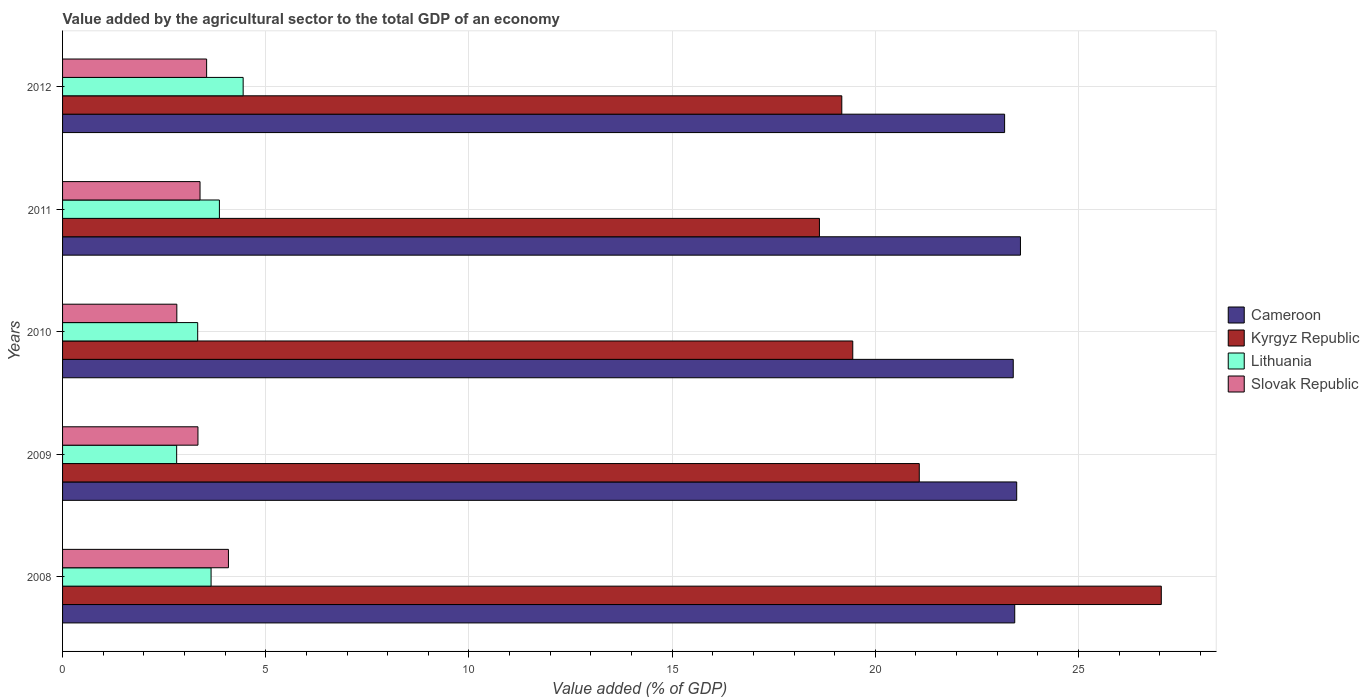Are the number of bars per tick equal to the number of legend labels?
Your answer should be compact. Yes. What is the label of the 1st group of bars from the top?
Make the answer very short. 2012. What is the value added by the agricultural sector to the total GDP in Slovak Republic in 2008?
Your response must be concise. 4.08. Across all years, what is the maximum value added by the agricultural sector to the total GDP in Slovak Republic?
Offer a terse response. 4.08. Across all years, what is the minimum value added by the agricultural sector to the total GDP in Lithuania?
Your answer should be compact. 2.81. In which year was the value added by the agricultural sector to the total GDP in Lithuania maximum?
Your answer should be compact. 2012. In which year was the value added by the agricultural sector to the total GDP in Lithuania minimum?
Your response must be concise. 2009. What is the total value added by the agricultural sector to the total GDP in Lithuania in the graph?
Provide a short and direct response. 18.09. What is the difference between the value added by the agricultural sector to the total GDP in Slovak Republic in 2008 and that in 2010?
Your answer should be very brief. 1.27. What is the difference between the value added by the agricultural sector to the total GDP in Cameroon in 2009 and the value added by the agricultural sector to the total GDP in Kyrgyz Republic in 2011?
Give a very brief answer. 4.85. What is the average value added by the agricultural sector to the total GDP in Slovak Republic per year?
Offer a terse response. 3.43. In the year 2012, what is the difference between the value added by the agricultural sector to the total GDP in Kyrgyz Republic and value added by the agricultural sector to the total GDP in Lithuania?
Your answer should be compact. 14.73. What is the ratio of the value added by the agricultural sector to the total GDP in Lithuania in 2009 to that in 2012?
Provide a short and direct response. 0.63. What is the difference between the highest and the second highest value added by the agricultural sector to the total GDP in Cameroon?
Offer a terse response. 0.09. What is the difference between the highest and the lowest value added by the agricultural sector to the total GDP in Cameroon?
Provide a succinct answer. 0.39. In how many years, is the value added by the agricultural sector to the total GDP in Kyrgyz Republic greater than the average value added by the agricultural sector to the total GDP in Kyrgyz Republic taken over all years?
Your answer should be very brief. 2. Is it the case that in every year, the sum of the value added by the agricultural sector to the total GDP in Cameroon and value added by the agricultural sector to the total GDP in Slovak Republic is greater than the sum of value added by the agricultural sector to the total GDP in Lithuania and value added by the agricultural sector to the total GDP in Kyrgyz Republic?
Your answer should be compact. Yes. What does the 4th bar from the top in 2009 represents?
Give a very brief answer. Cameroon. What does the 2nd bar from the bottom in 2009 represents?
Ensure brevity in your answer.  Kyrgyz Republic. Is it the case that in every year, the sum of the value added by the agricultural sector to the total GDP in Slovak Republic and value added by the agricultural sector to the total GDP in Kyrgyz Republic is greater than the value added by the agricultural sector to the total GDP in Lithuania?
Provide a short and direct response. Yes. Are all the bars in the graph horizontal?
Make the answer very short. Yes. How many years are there in the graph?
Make the answer very short. 5. What is the title of the graph?
Offer a very short reply. Value added by the agricultural sector to the total GDP of an economy. Does "Vanuatu" appear as one of the legend labels in the graph?
Ensure brevity in your answer.  No. What is the label or title of the X-axis?
Make the answer very short. Value added (% of GDP). What is the Value added (% of GDP) of Cameroon in 2008?
Give a very brief answer. 23.43. What is the Value added (% of GDP) in Kyrgyz Republic in 2008?
Your response must be concise. 27.04. What is the Value added (% of GDP) in Lithuania in 2008?
Your answer should be very brief. 3.65. What is the Value added (% of GDP) in Slovak Republic in 2008?
Make the answer very short. 4.08. What is the Value added (% of GDP) in Cameroon in 2009?
Make the answer very short. 23.48. What is the Value added (% of GDP) of Kyrgyz Republic in 2009?
Offer a terse response. 21.08. What is the Value added (% of GDP) in Lithuania in 2009?
Give a very brief answer. 2.81. What is the Value added (% of GDP) of Slovak Republic in 2009?
Provide a short and direct response. 3.33. What is the Value added (% of GDP) in Cameroon in 2010?
Your response must be concise. 23.39. What is the Value added (% of GDP) in Kyrgyz Republic in 2010?
Give a very brief answer. 19.44. What is the Value added (% of GDP) in Lithuania in 2010?
Keep it short and to the point. 3.33. What is the Value added (% of GDP) in Slovak Republic in 2010?
Give a very brief answer. 2.81. What is the Value added (% of GDP) in Cameroon in 2011?
Your answer should be very brief. 23.57. What is the Value added (% of GDP) in Kyrgyz Republic in 2011?
Provide a short and direct response. 18.62. What is the Value added (% of GDP) of Lithuania in 2011?
Offer a terse response. 3.86. What is the Value added (% of GDP) in Slovak Republic in 2011?
Your answer should be very brief. 3.38. What is the Value added (% of GDP) in Cameroon in 2012?
Your response must be concise. 23.18. What is the Value added (% of GDP) in Kyrgyz Republic in 2012?
Offer a terse response. 19.18. What is the Value added (% of GDP) of Lithuania in 2012?
Your answer should be very brief. 4.44. What is the Value added (% of GDP) of Slovak Republic in 2012?
Provide a succinct answer. 3.54. Across all years, what is the maximum Value added (% of GDP) of Cameroon?
Keep it short and to the point. 23.57. Across all years, what is the maximum Value added (% of GDP) of Kyrgyz Republic?
Your answer should be compact. 27.04. Across all years, what is the maximum Value added (% of GDP) in Lithuania?
Offer a very short reply. 4.44. Across all years, what is the maximum Value added (% of GDP) in Slovak Republic?
Your answer should be compact. 4.08. Across all years, what is the minimum Value added (% of GDP) in Cameroon?
Your response must be concise. 23.18. Across all years, what is the minimum Value added (% of GDP) of Kyrgyz Republic?
Provide a succinct answer. 18.62. Across all years, what is the minimum Value added (% of GDP) of Lithuania?
Ensure brevity in your answer.  2.81. Across all years, what is the minimum Value added (% of GDP) of Slovak Republic?
Your answer should be very brief. 2.81. What is the total Value added (% of GDP) in Cameroon in the graph?
Provide a succinct answer. 117.06. What is the total Value added (% of GDP) of Kyrgyz Republic in the graph?
Make the answer very short. 105.36. What is the total Value added (% of GDP) in Lithuania in the graph?
Your answer should be very brief. 18.09. What is the total Value added (% of GDP) in Slovak Republic in the graph?
Offer a very short reply. 17.15. What is the difference between the Value added (% of GDP) of Cameroon in 2008 and that in 2009?
Provide a short and direct response. -0.05. What is the difference between the Value added (% of GDP) in Kyrgyz Republic in 2008 and that in 2009?
Ensure brevity in your answer.  5.96. What is the difference between the Value added (% of GDP) of Lithuania in 2008 and that in 2009?
Make the answer very short. 0.85. What is the difference between the Value added (% of GDP) in Slovak Republic in 2008 and that in 2009?
Your answer should be very brief. 0.75. What is the difference between the Value added (% of GDP) of Cameroon in 2008 and that in 2010?
Provide a succinct answer. 0.04. What is the difference between the Value added (% of GDP) of Kyrgyz Republic in 2008 and that in 2010?
Provide a short and direct response. 7.59. What is the difference between the Value added (% of GDP) of Lithuania in 2008 and that in 2010?
Your answer should be very brief. 0.33. What is the difference between the Value added (% of GDP) of Slovak Republic in 2008 and that in 2010?
Offer a very short reply. 1.27. What is the difference between the Value added (% of GDP) of Cameroon in 2008 and that in 2011?
Ensure brevity in your answer.  -0.14. What is the difference between the Value added (% of GDP) of Kyrgyz Republic in 2008 and that in 2011?
Provide a succinct answer. 8.41. What is the difference between the Value added (% of GDP) of Lithuania in 2008 and that in 2011?
Your answer should be compact. -0.21. What is the difference between the Value added (% of GDP) in Slovak Republic in 2008 and that in 2011?
Ensure brevity in your answer.  0.7. What is the difference between the Value added (% of GDP) in Cameroon in 2008 and that in 2012?
Provide a succinct answer. 0.25. What is the difference between the Value added (% of GDP) of Kyrgyz Republic in 2008 and that in 2012?
Provide a short and direct response. 7.86. What is the difference between the Value added (% of GDP) of Lithuania in 2008 and that in 2012?
Ensure brevity in your answer.  -0.79. What is the difference between the Value added (% of GDP) in Slovak Republic in 2008 and that in 2012?
Offer a very short reply. 0.54. What is the difference between the Value added (% of GDP) in Cameroon in 2009 and that in 2010?
Your answer should be compact. 0.08. What is the difference between the Value added (% of GDP) in Kyrgyz Republic in 2009 and that in 2010?
Make the answer very short. 1.64. What is the difference between the Value added (% of GDP) in Lithuania in 2009 and that in 2010?
Provide a short and direct response. -0.52. What is the difference between the Value added (% of GDP) of Slovak Republic in 2009 and that in 2010?
Ensure brevity in your answer.  0.52. What is the difference between the Value added (% of GDP) of Cameroon in 2009 and that in 2011?
Give a very brief answer. -0.09. What is the difference between the Value added (% of GDP) of Kyrgyz Republic in 2009 and that in 2011?
Keep it short and to the point. 2.46. What is the difference between the Value added (% of GDP) in Lithuania in 2009 and that in 2011?
Give a very brief answer. -1.05. What is the difference between the Value added (% of GDP) in Slovak Republic in 2009 and that in 2011?
Provide a succinct answer. -0.05. What is the difference between the Value added (% of GDP) in Cameroon in 2009 and that in 2012?
Make the answer very short. 0.3. What is the difference between the Value added (% of GDP) of Kyrgyz Republic in 2009 and that in 2012?
Keep it short and to the point. 1.91. What is the difference between the Value added (% of GDP) in Lithuania in 2009 and that in 2012?
Ensure brevity in your answer.  -1.64. What is the difference between the Value added (% of GDP) of Slovak Republic in 2009 and that in 2012?
Provide a succinct answer. -0.21. What is the difference between the Value added (% of GDP) of Cameroon in 2010 and that in 2011?
Your answer should be very brief. -0.18. What is the difference between the Value added (% of GDP) of Kyrgyz Republic in 2010 and that in 2011?
Your answer should be compact. 0.82. What is the difference between the Value added (% of GDP) in Lithuania in 2010 and that in 2011?
Ensure brevity in your answer.  -0.53. What is the difference between the Value added (% of GDP) in Slovak Republic in 2010 and that in 2011?
Give a very brief answer. -0.57. What is the difference between the Value added (% of GDP) in Cameroon in 2010 and that in 2012?
Provide a succinct answer. 0.21. What is the difference between the Value added (% of GDP) in Kyrgyz Republic in 2010 and that in 2012?
Your answer should be compact. 0.27. What is the difference between the Value added (% of GDP) in Lithuania in 2010 and that in 2012?
Offer a very short reply. -1.12. What is the difference between the Value added (% of GDP) of Slovak Republic in 2010 and that in 2012?
Provide a succinct answer. -0.73. What is the difference between the Value added (% of GDP) of Cameroon in 2011 and that in 2012?
Make the answer very short. 0.39. What is the difference between the Value added (% of GDP) of Kyrgyz Republic in 2011 and that in 2012?
Provide a succinct answer. -0.55. What is the difference between the Value added (% of GDP) of Lithuania in 2011 and that in 2012?
Offer a very short reply. -0.58. What is the difference between the Value added (% of GDP) of Slovak Republic in 2011 and that in 2012?
Give a very brief answer. -0.16. What is the difference between the Value added (% of GDP) of Cameroon in 2008 and the Value added (% of GDP) of Kyrgyz Republic in 2009?
Make the answer very short. 2.35. What is the difference between the Value added (% of GDP) of Cameroon in 2008 and the Value added (% of GDP) of Lithuania in 2009?
Offer a terse response. 20.62. What is the difference between the Value added (% of GDP) of Cameroon in 2008 and the Value added (% of GDP) of Slovak Republic in 2009?
Keep it short and to the point. 20.1. What is the difference between the Value added (% of GDP) of Kyrgyz Republic in 2008 and the Value added (% of GDP) of Lithuania in 2009?
Provide a short and direct response. 24.23. What is the difference between the Value added (% of GDP) in Kyrgyz Republic in 2008 and the Value added (% of GDP) in Slovak Republic in 2009?
Offer a very short reply. 23.71. What is the difference between the Value added (% of GDP) of Lithuania in 2008 and the Value added (% of GDP) of Slovak Republic in 2009?
Offer a very short reply. 0.32. What is the difference between the Value added (% of GDP) of Cameroon in 2008 and the Value added (% of GDP) of Kyrgyz Republic in 2010?
Make the answer very short. 3.99. What is the difference between the Value added (% of GDP) in Cameroon in 2008 and the Value added (% of GDP) in Lithuania in 2010?
Provide a succinct answer. 20.11. What is the difference between the Value added (% of GDP) of Cameroon in 2008 and the Value added (% of GDP) of Slovak Republic in 2010?
Ensure brevity in your answer.  20.62. What is the difference between the Value added (% of GDP) of Kyrgyz Republic in 2008 and the Value added (% of GDP) of Lithuania in 2010?
Your response must be concise. 23.71. What is the difference between the Value added (% of GDP) in Kyrgyz Republic in 2008 and the Value added (% of GDP) in Slovak Republic in 2010?
Provide a succinct answer. 24.23. What is the difference between the Value added (% of GDP) of Lithuania in 2008 and the Value added (% of GDP) of Slovak Republic in 2010?
Your answer should be compact. 0.84. What is the difference between the Value added (% of GDP) of Cameroon in 2008 and the Value added (% of GDP) of Kyrgyz Republic in 2011?
Ensure brevity in your answer.  4.81. What is the difference between the Value added (% of GDP) in Cameroon in 2008 and the Value added (% of GDP) in Lithuania in 2011?
Give a very brief answer. 19.57. What is the difference between the Value added (% of GDP) in Cameroon in 2008 and the Value added (% of GDP) in Slovak Republic in 2011?
Your answer should be very brief. 20.05. What is the difference between the Value added (% of GDP) in Kyrgyz Republic in 2008 and the Value added (% of GDP) in Lithuania in 2011?
Give a very brief answer. 23.18. What is the difference between the Value added (% of GDP) of Kyrgyz Republic in 2008 and the Value added (% of GDP) of Slovak Republic in 2011?
Give a very brief answer. 23.65. What is the difference between the Value added (% of GDP) in Lithuania in 2008 and the Value added (% of GDP) in Slovak Republic in 2011?
Keep it short and to the point. 0.27. What is the difference between the Value added (% of GDP) of Cameroon in 2008 and the Value added (% of GDP) of Kyrgyz Republic in 2012?
Your response must be concise. 4.26. What is the difference between the Value added (% of GDP) of Cameroon in 2008 and the Value added (% of GDP) of Lithuania in 2012?
Your answer should be very brief. 18.99. What is the difference between the Value added (% of GDP) of Cameroon in 2008 and the Value added (% of GDP) of Slovak Republic in 2012?
Provide a short and direct response. 19.89. What is the difference between the Value added (% of GDP) in Kyrgyz Republic in 2008 and the Value added (% of GDP) in Lithuania in 2012?
Make the answer very short. 22.59. What is the difference between the Value added (% of GDP) in Kyrgyz Republic in 2008 and the Value added (% of GDP) in Slovak Republic in 2012?
Ensure brevity in your answer.  23.49. What is the difference between the Value added (% of GDP) of Lithuania in 2008 and the Value added (% of GDP) of Slovak Republic in 2012?
Keep it short and to the point. 0.11. What is the difference between the Value added (% of GDP) in Cameroon in 2009 and the Value added (% of GDP) in Kyrgyz Republic in 2010?
Provide a short and direct response. 4.03. What is the difference between the Value added (% of GDP) in Cameroon in 2009 and the Value added (% of GDP) in Lithuania in 2010?
Give a very brief answer. 20.15. What is the difference between the Value added (% of GDP) of Cameroon in 2009 and the Value added (% of GDP) of Slovak Republic in 2010?
Your response must be concise. 20.67. What is the difference between the Value added (% of GDP) of Kyrgyz Republic in 2009 and the Value added (% of GDP) of Lithuania in 2010?
Offer a terse response. 17.76. What is the difference between the Value added (% of GDP) of Kyrgyz Republic in 2009 and the Value added (% of GDP) of Slovak Republic in 2010?
Your answer should be very brief. 18.27. What is the difference between the Value added (% of GDP) of Lithuania in 2009 and the Value added (% of GDP) of Slovak Republic in 2010?
Provide a succinct answer. -0. What is the difference between the Value added (% of GDP) in Cameroon in 2009 and the Value added (% of GDP) in Kyrgyz Republic in 2011?
Your response must be concise. 4.85. What is the difference between the Value added (% of GDP) in Cameroon in 2009 and the Value added (% of GDP) in Lithuania in 2011?
Provide a succinct answer. 19.62. What is the difference between the Value added (% of GDP) of Cameroon in 2009 and the Value added (% of GDP) of Slovak Republic in 2011?
Ensure brevity in your answer.  20.1. What is the difference between the Value added (% of GDP) of Kyrgyz Republic in 2009 and the Value added (% of GDP) of Lithuania in 2011?
Your answer should be very brief. 17.22. What is the difference between the Value added (% of GDP) in Kyrgyz Republic in 2009 and the Value added (% of GDP) in Slovak Republic in 2011?
Give a very brief answer. 17.7. What is the difference between the Value added (% of GDP) of Lithuania in 2009 and the Value added (% of GDP) of Slovak Republic in 2011?
Provide a short and direct response. -0.58. What is the difference between the Value added (% of GDP) in Cameroon in 2009 and the Value added (% of GDP) in Kyrgyz Republic in 2012?
Provide a short and direct response. 4.3. What is the difference between the Value added (% of GDP) of Cameroon in 2009 and the Value added (% of GDP) of Lithuania in 2012?
Offer a terse response. 19.04. What is the difference between the Value added (% of GDP) of Cameroon in 2009 and the Value added (% of GDP) of Slovak Republic in 2012?
Keep it short and to the point. 19.93. What is the difference between the Value added (% of GDP) in Kyrgyz Republic in 2009 and the Value added (% of GDP) in Lithuania in 2012?
Keep it short and to the point. 16.64. What is the difference between the Value added (% of GDP) of Kyrgyz Republic in 2009 and the Value added (% of GDP) of Slovak Republic in 2012?
Offer a very short reply. 17.54. What is the difference between the Value added (% of GDP) of Lithuania in 2009 and the Value added (% of GDP) of Slovak Republic in 2012?
Provide a succinct answer. -0.74. What is the difference between the Value added (% of GDP) of Cameroon in 2010 and the Value added (% of GDP) of Kyrgyz Republic in 2011?
Make the answer very short. 4.77. What is the difference between the Value added (% of GDP) of Cameroon in 2010 and the Value added (% of GDP) of Lithuania in 2011?
Keep it short and to the point. 19.53. What is the difference between the Value added (% of GDP) in Cameroon in 2010 and the Value added (% of GDP) in Slovak Republic in 2011?
Your answer should be compact. 20.01. What is the difference between the Value added (% of GDP) of Kyrgyz Republic in 2010 and the Value added (% of GDP) of Lithuania in 2011?
Ensure brevity in your answer.  15.59. What is the difference between the Value added (% of GDP) of Kyrgyz Republic in 2010 and the Value added (% of GDP) of Slovak Republic in 2011?
Ensure brevity in your answer.  16.06. What is the difference between the Value added (% of GDP) of Lithuania in 2010 and the Value added (% of GDP) of Slovak Republic in 2011?
Your answer should be very brief. -0.06. What is the difference between the Value added (% of GDP) of Cameroon in 2010 and the Value added (% of GDP) of Kyrgyz Republic in 2012?
Your response must be concise. 4.22. What is the difference between the Value added (% of GDP) of Cameroon in 2010 and the Value added (% of GDP) of Lithuania in 2012?
Ensure brevity in your answer.  18.95. What is the difference between the Value added (% of GDP) of Cameroon in 2010 and the Value added (% of GDP) of Slovak Republic in 2012?
Provide a succinct answer. 19.85. What is the difference between the Value added (% of GDP) in Kyrgyz Republic in 2010 and the Value added (% of GDP) in Lithuania in 2012?
Provide a succinct answer. 15. What is the difference between the Value added (% of GDP) in Kyrgyz Republic in 2010 and the Value added (% of GDP) in Slovak Republic in 2012?
Your response must be concise. 15.9. What is the difference between the Value added (% of GDP) in Lithuania in 2010 and the Value added (% of GDP) in Slovak Republic in 2012?
Provide a short and direct response. -0.22. What is the difference between the Value added (% of GDP) of Cameroon in 2011 and the Value added (% of GDP) of Kyrgyz Republic in 2012?
Your response must be concise. 4.4. What is the difference between the Value added (% of GDP) in Cameroon in 2011 and the Value added (% of GDP) in Lithuania in 2012?
Provide a succinct answer. 19.13. What is the difference between the Value added (% of GDP) in Cameroon in 2011 and the Value added (% of GDP) in Slovak Republic in 2012?
Your response must be concise. 20.03. What is the difference between the Value added (% of GDP) in Kyrgyz Republic in 2011 and the Value added (% of GDP) in Lithuania in 2012?
Ensure brevity in your answer.  14.18. What is the difference between the Value added (% of GDP) in Kyrgyz Republic in 2011 and the Value added (% of GDP) in Slovak Republic in 2012?
Offer a terse response. 15.08. What is the difference between the Value added (% of GDP) of Lithuania in 2011 and the Value added (% of GDP) of Slovak Republic in 2012?
Provide a succinct answer. 0.31. What is the average Value added (% of GDP) in Cameroon per year?
Your response must be concise. 23.41. What is the average Value added (% of GDP) in Kyrgyz Republic per year?
Provide a short and direct response. 21.07. What is the average Value added (% of GDP) of Lithuania per year?
Your answer should be very brief. 3.62. What is the average Value added (% of GDP) of Slovak Republic per year?
Your response must be concise. 3.43. In the year 2008, what is the difference between the Value added (% of GDP) of Cameroon and Value added (% of GDP) of Kyrgyz Republic?
Your response must be concise. -3.61. In the year 2008, what is the difference between the Value added (% of GDP) of Cameroon and Value added (% of GDP) of Lithuania?
Provide a succinct answer. 19.78. In the year 2008, what is the difference between the Value added (% of GDP) of Cameroon and Value added (% of GDP) of Slovak Republic?
Ensure brevity in your answer.  19.35. In the year 2008, what is the difference between the Value added (% of GDP) of Kyrgyz Republic and Value added (% of GDP) of Lithuania?
Give a very brief answer. 23.38. In the year 2008, what is the difference between the Value added (% of GDP) in Kyrgyz Republic and Value added (% of GDP) in Slovak Republic?
Offer a very short reply. 22.96. In the year 2008, what is the difference between the Value added (% of GDP) in Lithuania and Value added (% of GDP) in Slovak Republic?
Make the answer very short. -0.43. In the year 2009, what is the difference between the Value added (% of GDP) of Cameroon and Value added (% of GDP) of Kyrgyz Republic?
Offer a very short reply. 2.4. In the year 2009, what is the difference between the Value added (% of GDP) of Cameroon and Value added (% of GDP) of Lithuania?
Make the answer very short. 20.67. In the year 2009, what is the difference between the Value added (% of GDP) in Cameroon and Value added (% of GDP) in Slovak Republic?
Your response must be concise. 20.15. In the year 2009, what is the difference between the Value added (% of GDP) in Kyrgyz Republic and Value added (% of GDP) in Lithuania?
Keep it short and to the point. 18.27. In the year 2009, what is the difference between the Value added (% of GDP) of Kyrgyz Republic and Value added (% of GDP) of Slovak Republic?
Your answer should be compact. 17.75. In the year 2009, what is the difference between the Value added (% of GDP) of Lithuania and Value added (% of GDP) of Slovak Republic?
Ensure brevity in your answer.  -0.52. In the year 2010, what is the difference between the Value added (% of GDP) of Cameroon and Value added (% of GDP) of Kyrgyz Republic?
Give a very brief answer. 3.95. In the year 2010, what is the difference between the Value added (% of GDP) of Cameroon and Value added (% of GDP) of Lithuania?
Provide a succinct answer. 20.07. In the year 2010, what is the difference between the Value added (% of GDP) of Cameroon and Value added (% of GDP) of Slovak Republic?
Provide a short and direct response. 20.58. In the year 2010, what is the difference between the Value added (% of GDP) of Kyrgyz Republic and Value added (% of GDP) of Lithuania?
Keep it short and to the point. 16.12. In the year 2010, what is the difference between the Value added (% of GDP) of Kyrgyz Republic and Value added (% of GDP) of Slovak Republic?
Provide a short and direct response. 16.63. In the year 2010, what is the difference between the Value added (% of GDP) in Lithuania and Value added (% of GDP) in Slovak Republic?
Provide a succinct answer. 0.51. In the year 2011, what is the difference between the Value added (% of GDP) in Cameroon and Value added (% of GDP) in Kyrgyz Republic?
Provide a succinct answer. 4.95. In the year 2011, what is the difference between the Value added (% of GDP) of Cameroon and Value added (% of GDP) of Lithuania?
Give a very brief answer. 19.71. In the year 2011, what is the difference between the Value added (% of GDP) in Cameroon and Value added (% of GDP) in Slovak Republic?
Your answer should be compact. 20.19. In the year 2011, what is the difference between the Value added (% of GDP) of Kyrgyz Republic and Value added (% of GDP) of Lithuania?
Ensure brevity in your answer.  14.77. In the year 2011, what is the difference between the Value added (% of GDP) of Kyrgyz Republic and Value added (% of GDP) of Slovak Republic?
Your answer should be very brief. 15.24. In the year 2011, what is the difference between the Value added (% of GDP) in Lithuania and Value added (% of GDP) in Slovak Republic?
Provide a short and direct response. 0.48. In the year 2012, what is the difference between the Value added (% of GDP) in Cameroon and Value added (% of GDP) in Kyrgyz Republic?
Your answer should be compact. 4.01. In the year 2012, what is the difference between the Value added (% of GDP) of Cameroon and Value added (% of GDP) of Lithuania?
Keep it short and to the point. 18.74. In the year 2012, what is the difference between the Value added (% of GDP) in Cameroon and Value added (% of GDP) in Slovak Republic?
Your response must be concise. 19.64. In the year 2012, what is the difference between the Value added (% of GDP) in Kyrgyz Republic and Value added (% of GDP) in Lithuania?
Make the answer very short. 14.73. In the year 2012, what is the difference between the Value added (% of GDP) of Kyrgyz Republic and Value added (% of GDP) of Slovak Republic?
Give a very brief answer. 15.63. In the year 2012, what is the difference between the Value added (% of GDP) in Lithuania and Value added (% of GDP) in Slovak Republic?
Your answer should be compact. 0.9. What is the ratio of the Value added (% of GDP) in Cameroon in 2008 to that in 2009?
Ensure brevity in your answer.  1. What is the ratio of the Value added (% of GDP) of Kyrgyz Republic in 2008 to that in 2009?
Offer a very short reply. 1.28. What is the ratio of the Value added (% of GDP) of Lithuania in 2008 to that in 2009?
Provide a succinct answer. 1.3. What is the ratio of the Value added (% of GDP) of Slovak Republic in 2008 to that in 2009?
Keep it short and to the point. 1.23. What is the ratio of the Value added (% of GDP) of Cameroon in 2008 to that in 2010?
Keep it short and to the point. 1. What is the ratio of the Value added (% of GDP) in Kyrgyz Republic in 2008 to that in 2010?
Keep it short and to the point. 1.39. What is the ratio of the Value added (% of GDP) in Lithuania in 2008 to that in 2010?
Make the answer very short. 1.1. What is the ratio of the Value added (% of GDP) of Slovak Republic in 2008 to that in 2010?
Give a very brief answer. 1.45. What is the ratio of the Value added (% of GDP) of Cameroon in 2008 to that in 2011?
Offer a terse response. 0.99. What is the ratio of the Value added (% of GDP) of Kyrgyz Republic in 2008 to that in 2011?
Your answer should be very brief. 1.45. What is the ratio of the Value added (% of GDP) in Lithuania in 2008 to that in 2011?
Provide a succinct answer. 0.95. What is the ratio of the Value added (% of GDP) of Slovak Republic in 2008 to that in 2011?
Ensure brevity in your answer.  1.21. What is the ratio of the Value added (% of GDP) in Cameroon in 2008 to that in 2012?
Ensure brevity in your answer.  1.01. What is the ratio of the Value added (% of GDP) of Kyrgyz Republic in 2008 to that in 2012?
Your answer should be very brief. 1.41. What is the ratio of the Value added (% of GDP) in Lithuania in 2008 to that in 2012?
Your answer should be compact. 0.82. What is the ratio of the Value added (% of GDP) of Slovak Republic in 2008 to that in 2012?
Offer a terse response. 1.15. What is the ratio of the Value added (% of GDP) of Kyrgyz Republic in 2009 to that in 2010?
Ensure brevity in your answer.  1.08. What is the ratio of the Value added (% of GDP) in Lithuania in 2009 to that in 2010?
Keep it short and to the point. 0.84. What is the ratio of the Value added (% of GDP) in Slovak Republic in 2009 to that in 2010?
Provide a succinct answer. 1.18. What is the ratio of the Value added (% of GDP) of Cameroon in 2009 to that in 2011?
Give a very brief answer. 1. What is the ratio of the Value added (% of GDP) in Kyrgyz Republic in 2009 to that in 2011?
Ensure brevity in your answer.  1.13. What is the ratio of the Value added (% of GDP) of Lithuania in 2009 to that in 2011?
Provide a short and direct response. 0.73. What is the ratio of the Value added (% of GDP) of Slovak Republic in 2009 to that in 2011?
Provide a succinct answer. 0.98. What is the ratio of the Value added (% of GDP) of Cameroon in 2009 to that in 2012?
Your answer should be compact. 1.01. What is the ratio of the Value added (% of GDP) in Kyrgyz Republic in 2009 to that in 2012?
Your answer should be very brief. 1.1. What is the ratio of the Value added (% of GDP) in Lithuania in 2009 to that in 2012?
Offer a terse response. 0.63. What is the ratio of the Value added (% of GDP) of Slovak Republic in 2009 to that in 2012?
Offer a terse response. 0.94. What is the ratio of the Value added (% of GDP) in Kyrgyz Republic in 2010 to that in 2011?
Your answer should be very brief. 1.04. What is the ratio of the Value added (% of GDP) in Lithuania in 2010 to that in 2011?
Keep it short and to the point. 0.86. What is the ratio of the Value added (% of GDP) in Slovak Republic in 2010 to that in 2011?
Offer a very short reply. 0.83. What is the ratio of the Value added (% of GDP) of Cameroon in 2010 to that in 2012?
Provide a short and direct response. 1.01. What is the ratio of the Value added (% of GDP) of Kyrgyz Republic in 2010 to that in 2012?
Ensure brevity in your answer.  1.01. What is the ratio of the Value added (% of GDP) in Lithuania in 2010 to that in 2012?
Provide a succinct answer. 0.75. What is the ratio of the Value added (% of GDP) of Slovak Republic in 2010 to that in 2012?
Your response must be concise. 0.79. What is the ratio of the Value added (% of GDP) of Cameroon in 2011 to that in 2012?
Your answer should be very brief. 1.02. What is the ratio of the Value added (% of GDP) in Kyrgyz Republic in 2011 to that in 2012?
Keep it short and to the point. 0.97. What is the ratio of the Value added (% of GDP) in Lithuania in 2011 to that in 2012?
Your response must be concise. 0.87. What is the ratio of the Value added (% of GDP) in Slovak Republic in 2011 to that in 2012?
Ensure brevity in your answer.  0.95. What is the difference between the highest and the second highest Value added (% of GDP) in Cameroon?
Make the answer very short. 0.09. What is the difference between the highest and the second highest Value added (% of GDP) in Kyrgyz Republic?
Your response must be concise. 5.96. What is the difference between the highest and the second highest Value added (% of GDP) in Lithuania?
Ensure brevity in your answer.  0.58. What is the difference between the highest and the second highest Value added (% of GDP) of Slovak Republic?
Your response must be concise. 0.54. What is the difference between the highest and the lowest Value added (% of GDP) in Cameroon?
Make the answer very short. 0.39. What is the difference between the highest and the lowest Value added (% of GDP) in Kyrgyz Republic?
Your answer should be compact. 8.41. What is the difference between the highest and the lowest Value added (% of GDP) of Lithuania?
Offer a terse response. 1.64. What is the difference between the highest and the lowest Value added (% of GDP) in Slovak Republic?
Ensure brevity in your answer.  1.27. 